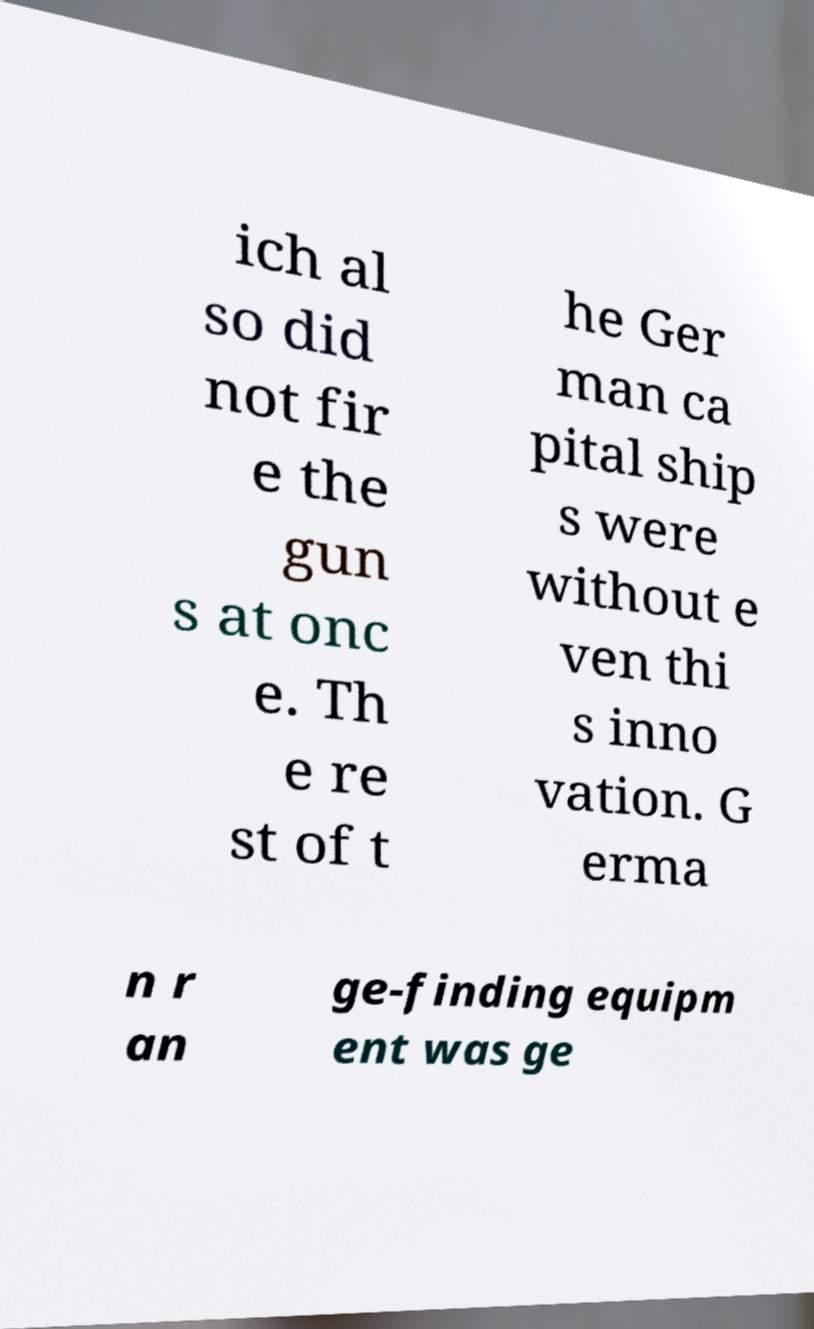I need the written content from this picture converted into text. Can you do that? ich al so did not fir e the gun s at onc e. Th e re st of t he Ger man ca pital ship s were without e ven thi s inno vation. G erma n r an ge-finding equipm ent was ge 